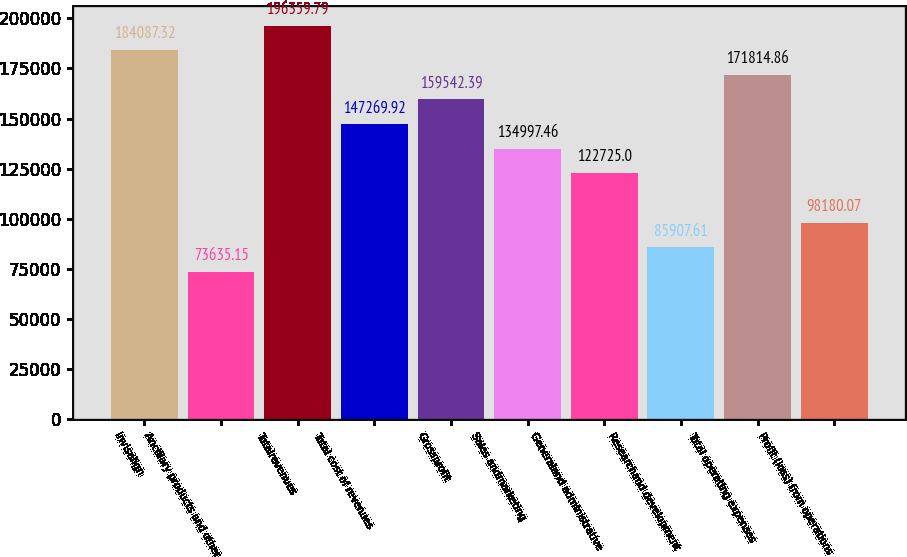Convert chart to OTSL. <chart><loc_0><loc_0><loc_500><loc_500><bar_chart><fcel>Invisalign<fcel>Ancillary products and other<fcel>Totalrevenues<fcel>Total cost of revenues<fcel>Grossprofit<fcel>Sales andmarketing<fcel>Generaland administrative<fcel>Researchand development<fcel>Total operating expenses<fcel>Profit (loss) from operations<nl><fcel>184087<fcel>73635.1<fcel>196360<fcel>147270<fcel>159542<fcel>134997<fcel>122725<fcel>85907.6<fcel>171815<fcel>98180.1<nl></chart> 